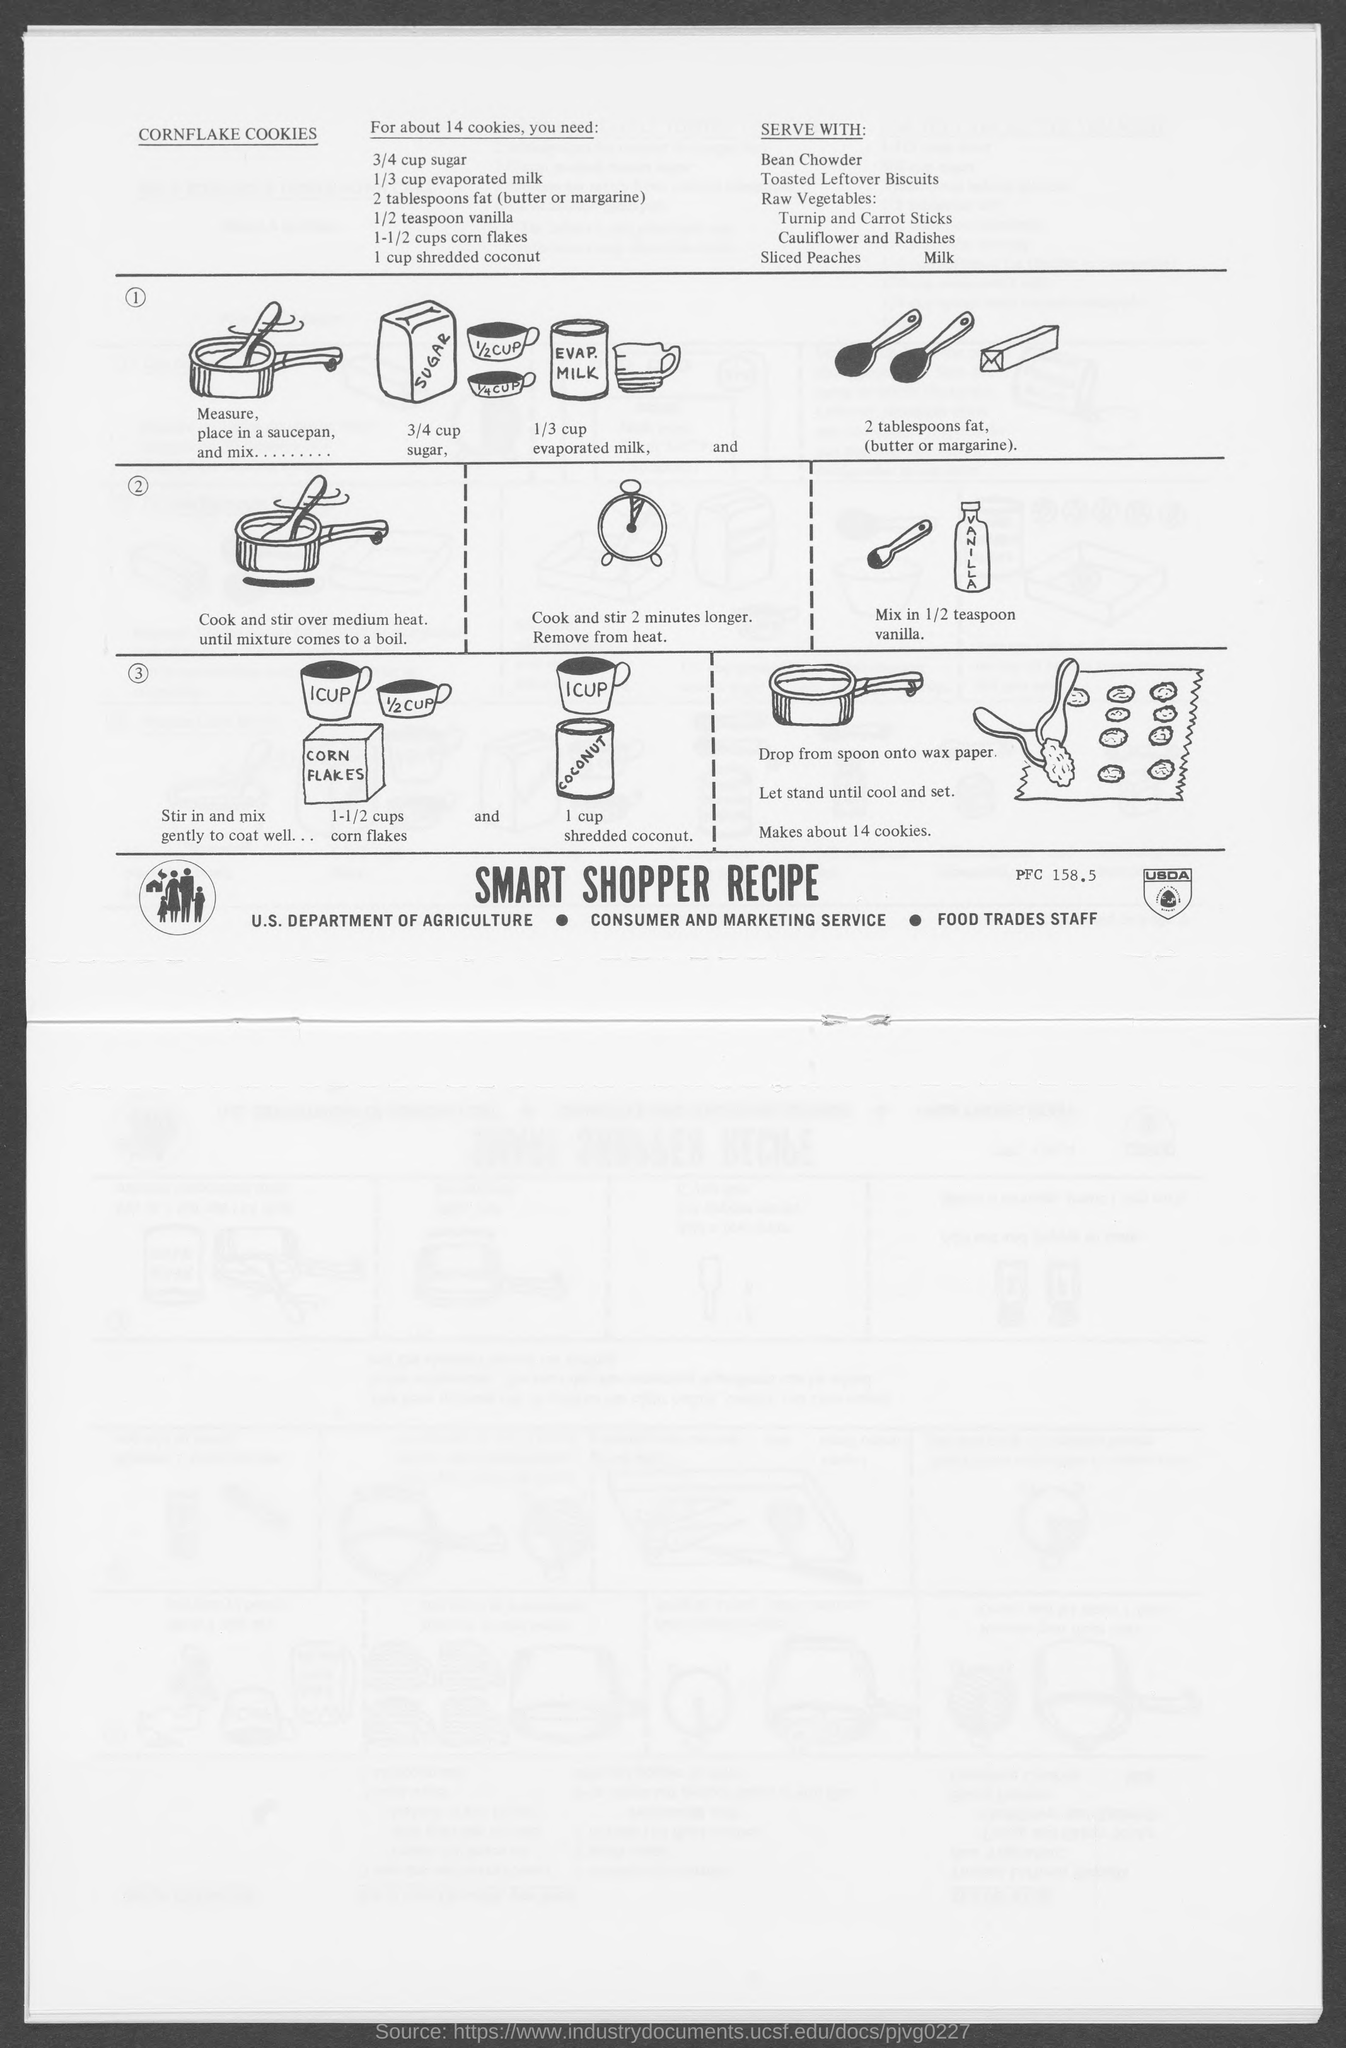Indicate a few pertinent items in this graphic. You have declared that there are 2 tablespoons of fat present. One-third cup of evaporated milk will be used in the recipe. The recipe for cornflake cookies involves the following ingredients: corn flakes, sugar, butter, eggs, and flour. I am consuming three-quarters of a cup of sugar. 